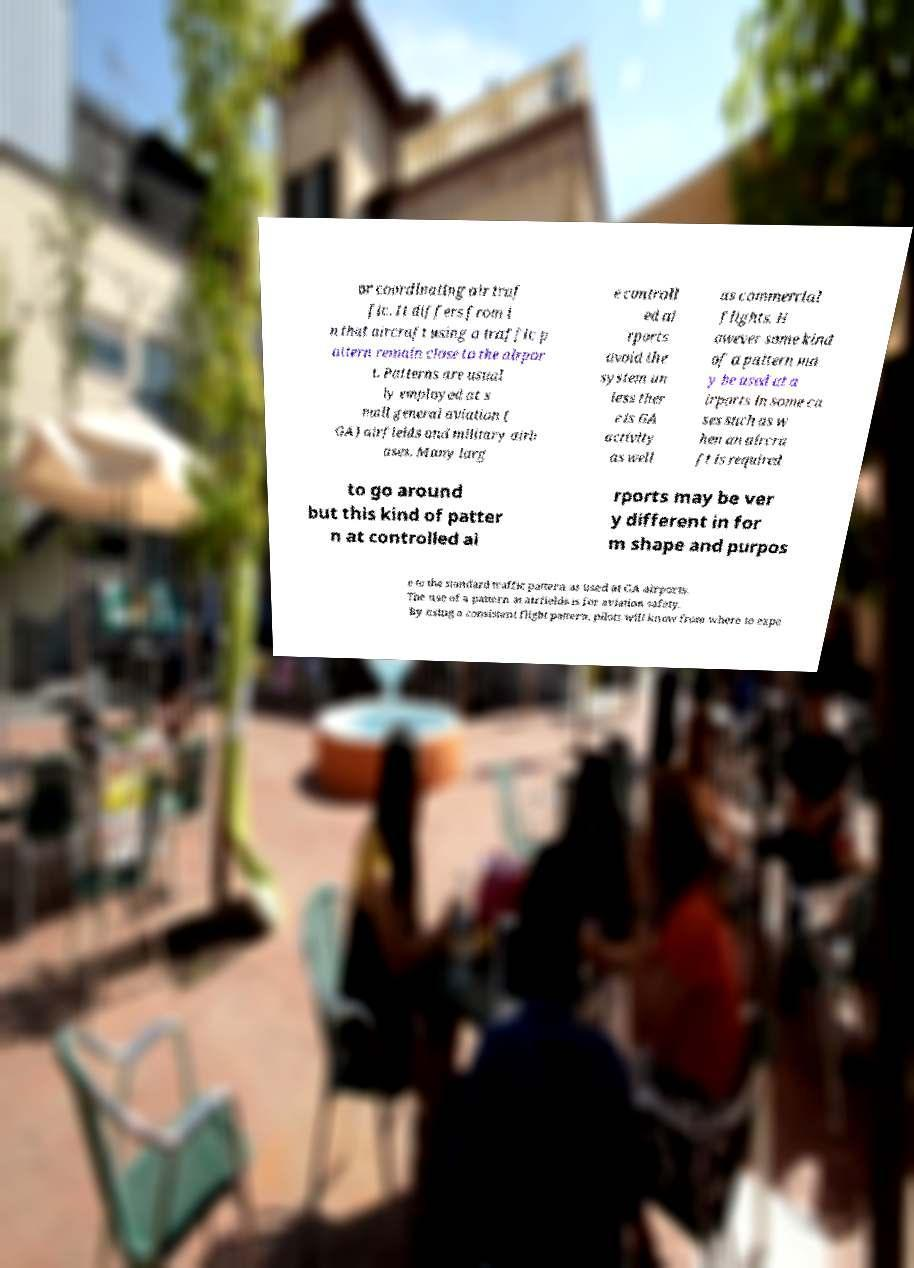I need the written content from this picture converted into text. Can you do that? or coordinating air traf fic. It differs from i n that aircraft using a traffic p attern remain close to the airpor t. Patterns are usual ly employed at s mall general aviation ( GA) airfields and military airb ases. Many larg e controll ed ai rports avoid the system un less ther e is GA activity as well as commercial flights. H owever some kind of a pattern ma y be used at a irports in some ca ses such as w hen an aircra ft is required to go around but this kind of patter n at controlled ai rports may be ver y different in for m shape and purpos e to the standard traffic pattern as used at GA airports. The use of a pattern at airfields is for aviation safety. By using a consistent flight pattern, pilots will know from where to expe 